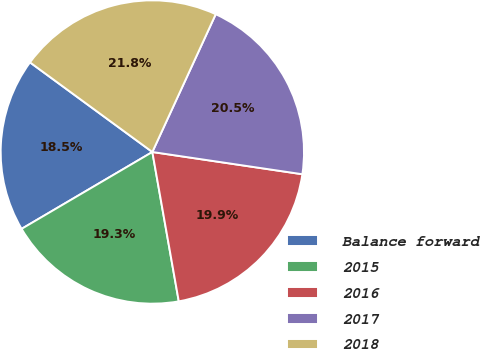<chart> <loc_0><loc_0><loc_500><loc_500><pie_chart><fcel>Balance forward<fcel>2015<fcel>2016<fcel>2017<fcel>2018<nl><fcel>18.52%<fcel>19.33%<fcel>19.87%<fcel>20.48%<fcel>21.8%<nl></chart> 